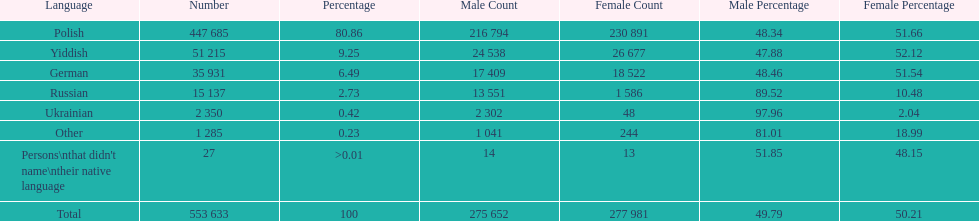How many languages have a name that is derived from a country? 4. 